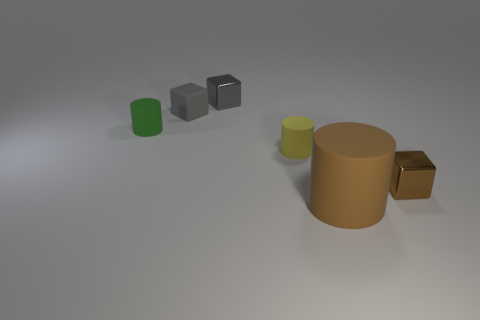What is the color of the other small thing that is the same shape as the small yellow rubber thing?
Provide a succinct answer. Green. What number of metal cubes have the same color as the matte block?
Make the answer very short. 1. Is the number of big brown cylinders on the right side of the large brown matte object greater than the number of tiny shiny cubes?
Keep it short and to the point. No. The small block to the right of the rubber thing that is right of the tiny yellow rubber thing is what color?
Provide a short and direct response. Brown. What number of things are small yellow rubber things that are behind the big brown rubber object or tiny matte things behind the yellow matte object?
Give a very brief answer. 3. The rubber cube is what color?
Offer a very short reply. Gray. How many other large brown objects have the same material as the big brown object?
Give a very brief answer. 0. Is the number of large brown metal balls greater than the number of tiny metal cubes?
Offer a terse response. No. There is a rubber cylinder in front of the brown metallic cube; what number of metal objects are right of it?
Make the answer very short. 1. How many objects are either metallic cubes in front of the green cylinder or yellow matte cylinders?
Your answer should be compact. 2. 